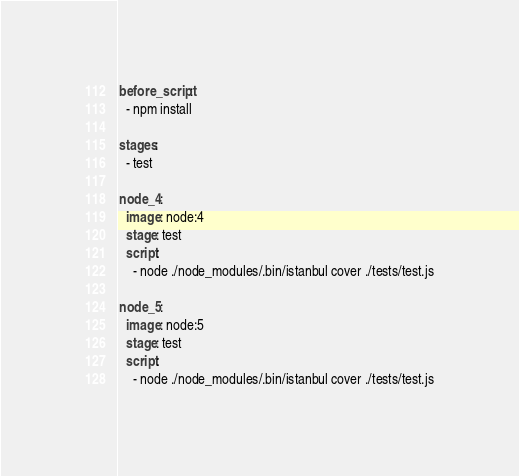<code> <loc_0><loc_0><loc_500><loc_500><_YAML_>before_script:
  - npm install

stages:
  - test

node_4:
  image: node:4
  stage: test
  script:
    - node ./node_modules/.bin/istanbul cover ./tests/test.js

node_5:
  image: node:5
  stage: test
  script:
    - node ./node_modules/.bin/istanbul cover ./tests/test.js
</code> 